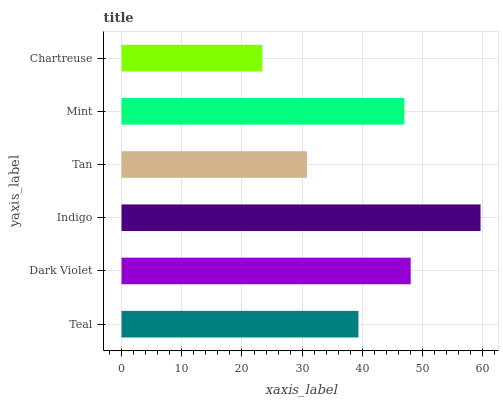Is Chartreuse the minimum?
Answer yes or no. Yes. Is Indigo the maximum?
Answer yes or no. Yes. Is Dark Violet the minimum?
Answer yes or no. No. Is Dark Violet the maximum?
Answer yes or no. No. Is Dark Violet greater than Teal?
Answer yes or no. Yes. Is Teal less than Dark Violet?
Answer yes or no. Yes. Is Teal greater than Dark Violet?
Answer yes or no. No. Is Dark Violet less than Teal?
Answer yes or no. No. Is Mint the high median?
Answer yes or no. Yes. Is Teal the low median?
Answer yes or no. Yes. Is Teal the high median?
Answer yes or no. No. Is Dark Violet the low median?
Answer yes or no. No. 